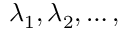Convert formula to latex. <formula><loc_0><loc_0><loc_500><loc_500>\lambda _ { 1 } , \lambda _ { 2 } , \dots ,</formula> 